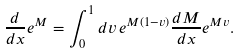Convert formula to latex. <formula><loc_0><loc_0><loc_500><loc_500>\frac { d } { d x } e ^ { M } = \int _ { 0 } ^ { 1 } d v \, e ^ { M ( 1 - v ) } \frac { d M } { d x } e ^ { M v } .</formula> 